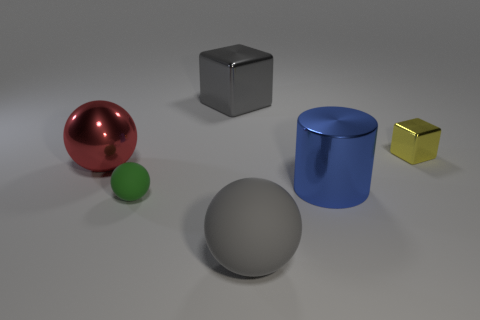What is the color of the big metal thing that is the same shape as the tiny green matte object?
Your answer should be compact. Red. There is a rubber thing that is the same size as the shiny cylinder; what color is it?
Provide a succinct answer. Gray. What is the size of the gray object that is the same shape as the tiny yellow thing?
Keep it short and to the point. Large. What is the shape of the tiny object that is to the left of the small yellow cube?
Ensure brevity in your answer.  Sphere. Do the red metal object and the small thing that is to the left of the big rubber object have the same shape?
Give a very brief answer. Yes. Are there an equal number of blocks to the right of the big shiny block and tiny cubes that are in front of the gray matte object?
Make the answer very short. No. There is a metallic object that is the same color as the large rubber thing; what is its shape?
Give a very brief answer. Cube. Does the large ball that is behind the cylinder have the same color as the shiny block that is to the right of the big metallic cube?
Your answer should be very brief. No. Are there more rubber objects that are to the right of the large gray ball than gray shiny objects?
Make the answer very short. No. What is the small green object made of?
Your response must be concise. Rubber. 